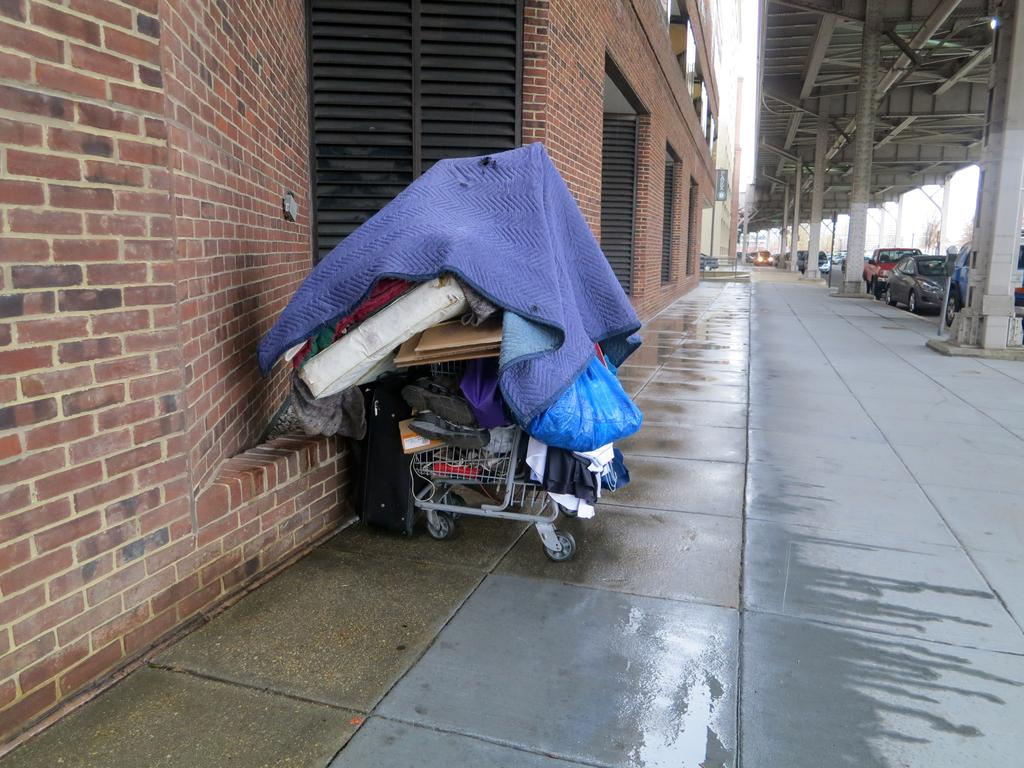What type of structures can be seen in the image? There are buildings in the image. What else can be found under a roof in the image? There are vehicles under a roof in the image. Can you describe the overall scene in the image? There are many objects in the image. What type of carriage can be seen in the image? There is no carriage present in the image. What type of board is being used to play a game in the image? There is no board game present in the image. 